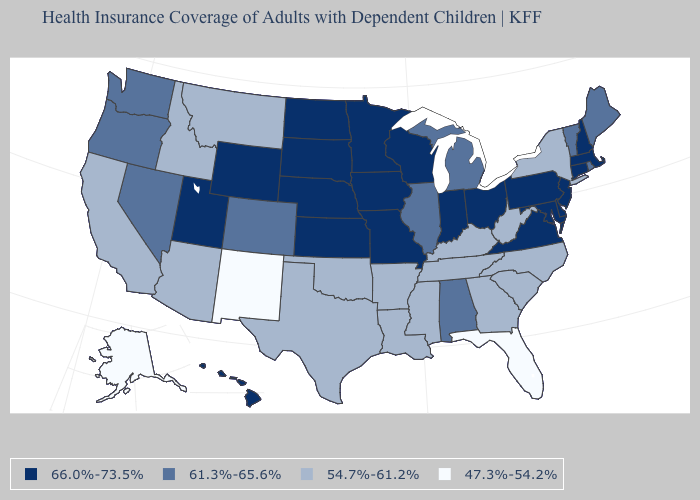Name the states that have a value in the range 47.3%-54.2%?
Short answer required. Alaska, Florida, New Mexico. Does Indiana have the lowest value in the MidWest?
Give a very brief answer. No. What is the value of Maine?
Short answer required. 61.3%-65.6%. Does Mississippi have the same value as Nevada?
Write a very short answer. No. What is the value of Kansas?
Short answer required. 66.0%-73.5%. Is the legend a continuous bar?
Keep it brief. No. Which states have the lowest value in the West?
Be succinct. Alaska, New Mexico. What is the value of Vermont?
Give a very brief answer. 61.3%-65.6%. What is the highest value in the USA?
Short answer required. 66.0%-73.5%. What is the value of Missouri?
Quick response, please. 66.0%-73.5%. Name the states that have a value in the range 47.3%-54.2%?
Answer briefly. Alaska, Florida, New Mexico. Name the states that have a value in the range 66.0%-73.5%?
Write a very short answer. Connecticut, Delaware, Hawaii, Indiana, Iowa, Kansas, Maryland, Massachusetts, Minnesota, Missouri, Nebraska, New Hampshire, New Jersey, North Dakota, Ohio, Pennsylvania, South Dakota, Utah, Virginia, Wisconsin, Wyoming. Does North Carolina have the lowest value in the USA?
Be succinct. No. Name the states that have a value in the range 66.0%-73.5%?
Write a very short answer. Connecticut, Delaware, Hawaii, Indiana, Iowa, Kansas, Maryland, Massachusetts, Minnesota, Missouri, Nebraska, New Hampshire, New Jersey, North Dakota, Ohio, Pennsylvania, South Dakota, Utah, Virginia, Wisconsin, Wyoming. Does Delaware have the same value as Alabama?
Give a very brief answer. No. 